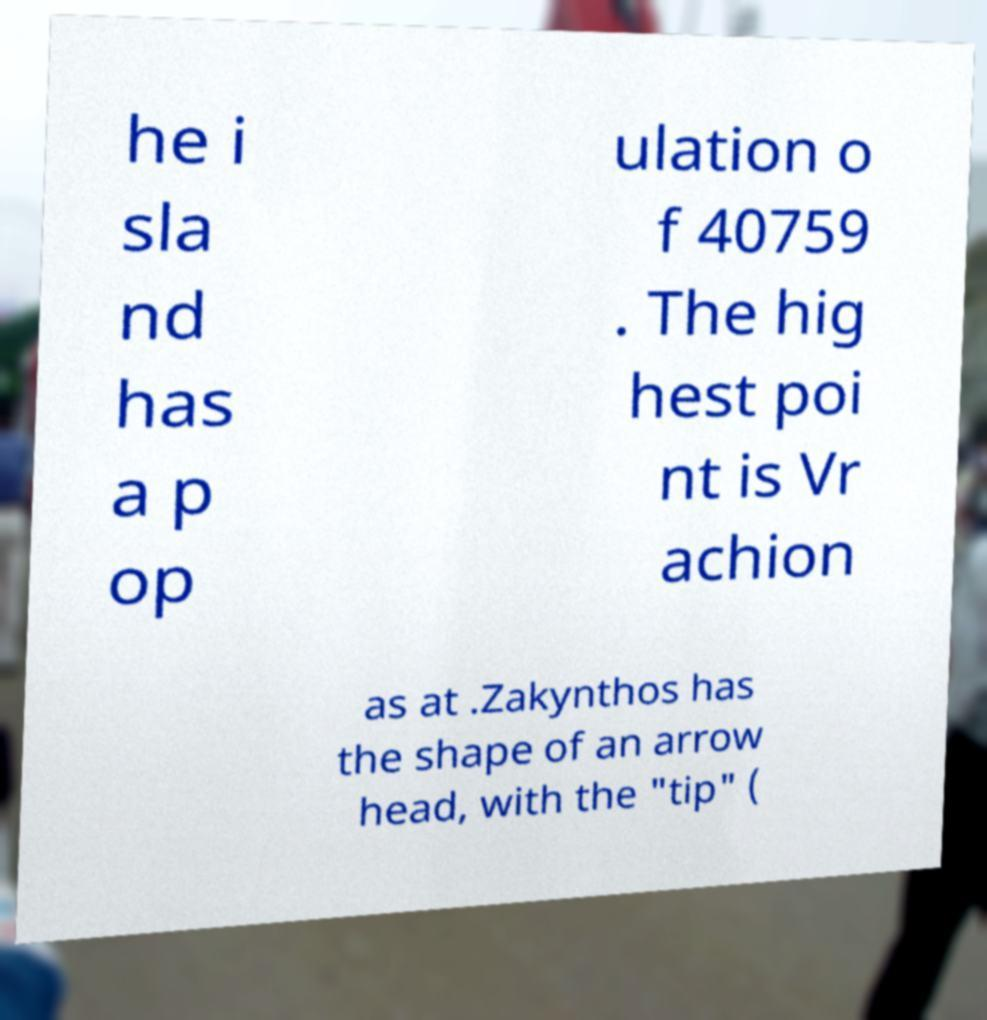There's text embedded in this image that I need extracted. Can you transcribe it verbatim? he i sla nd has a p op ulation o f 40759 . The hig hest poi nt is Vr achion as at .Zakynthos has the shape of an arrow head, with the "tip" ( 